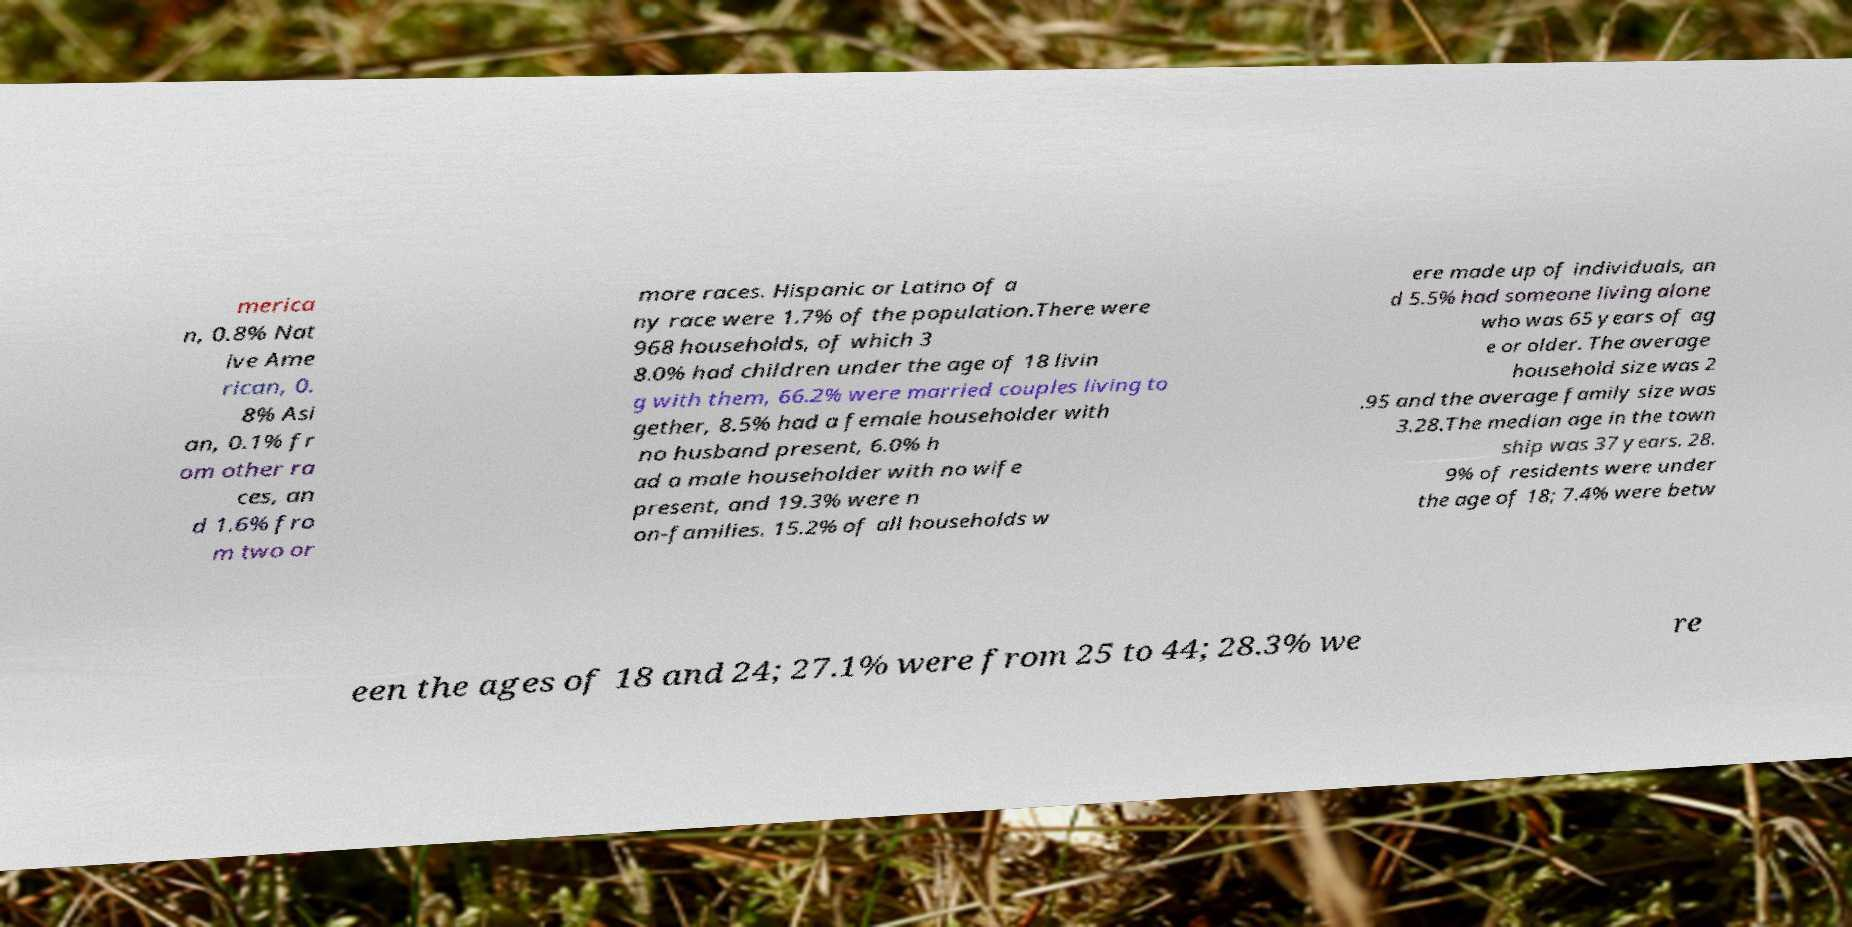What messages or text are displayed in this image? I need them in a readable, typed format. merica n, 0.8% Nat ive Ame rican, 0. 8% Asi an, 0.1% fr om other ra ces, an d 1.6% fro m two or more races. Hispanic or Latino of a ny race were 1.7% of the population.There were 968 households, of which 3 8.0% had children under the age of 18 livin g with them, 66.2% were married couples living to gether, 8.5% had a female householder with no husband present, 6.0% h ad a male householder with no wife present, and 19.3% were n on-families. 15.2% of all households w ere made up of individuals, an d 5.5% had someone living alone who was 65 years of ag e or older. The average household size was 2 .95 and the average family size was 3.28.The median age in the town ship was 37 years. 28. 9% of residents were under the age of 18; 7.4% were betw een the ages of 18 and 24; 27.1% were from 25 to 44; 28.3% we re 